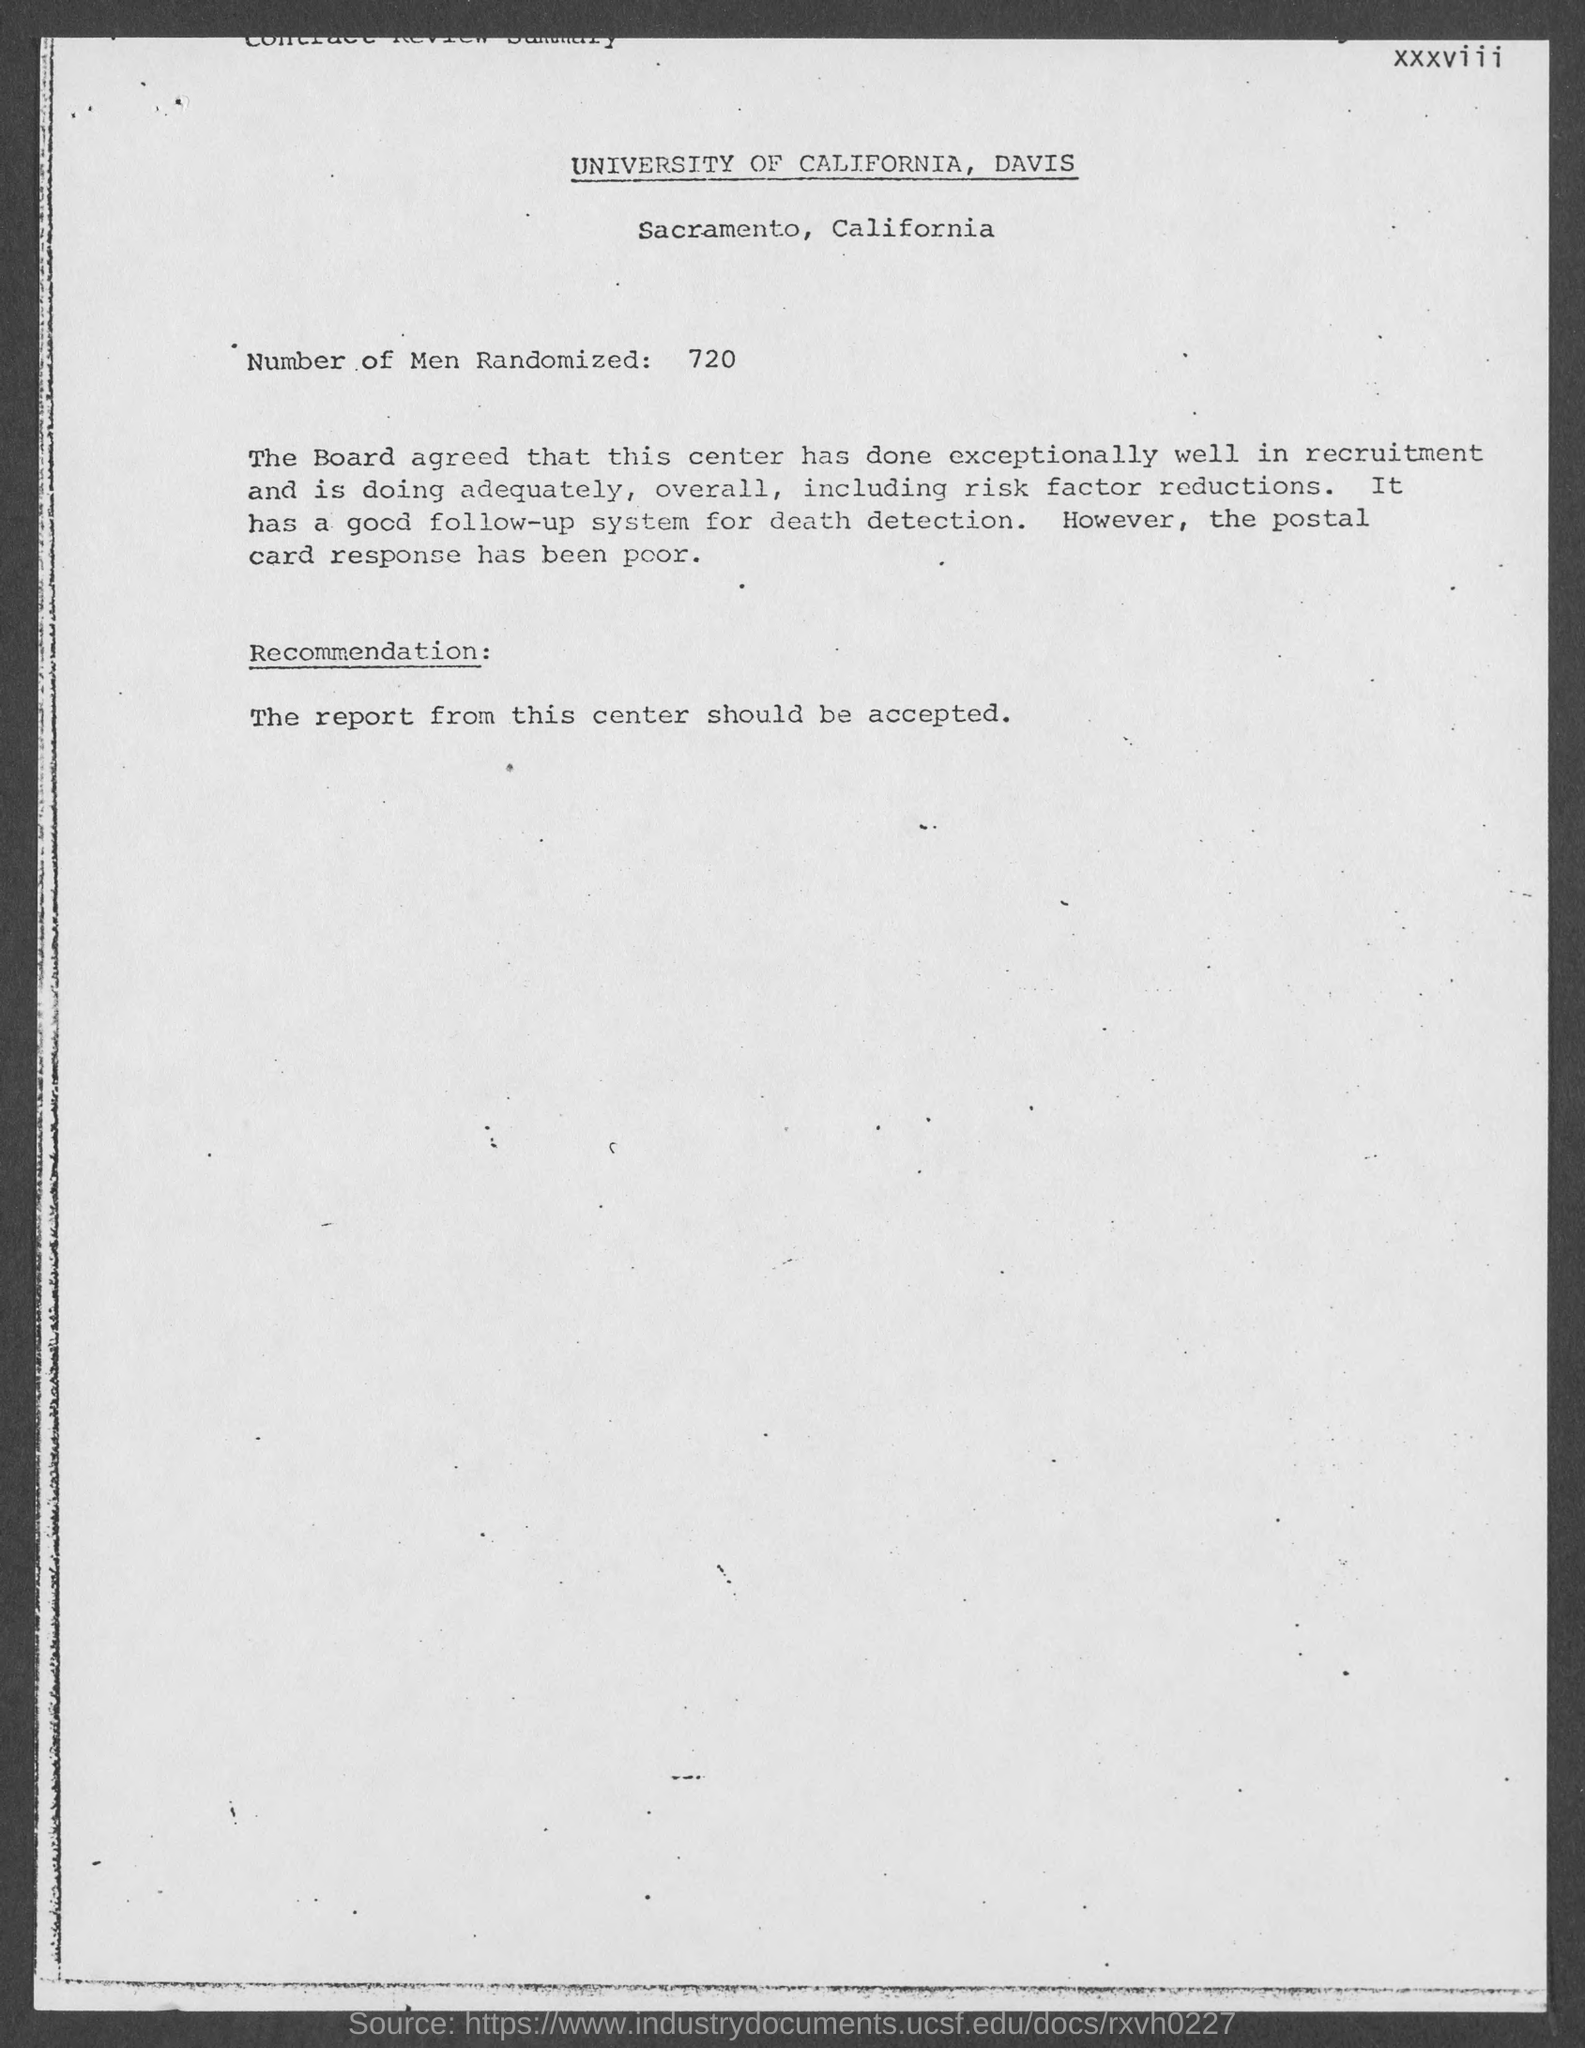Mention a couple of crucial points in this snapshot. A total of 720 participants were randomly selected for the study. 